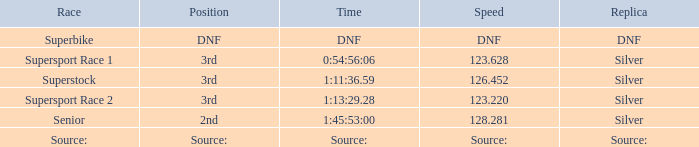Which race has a replica of DNF? Superbike. 